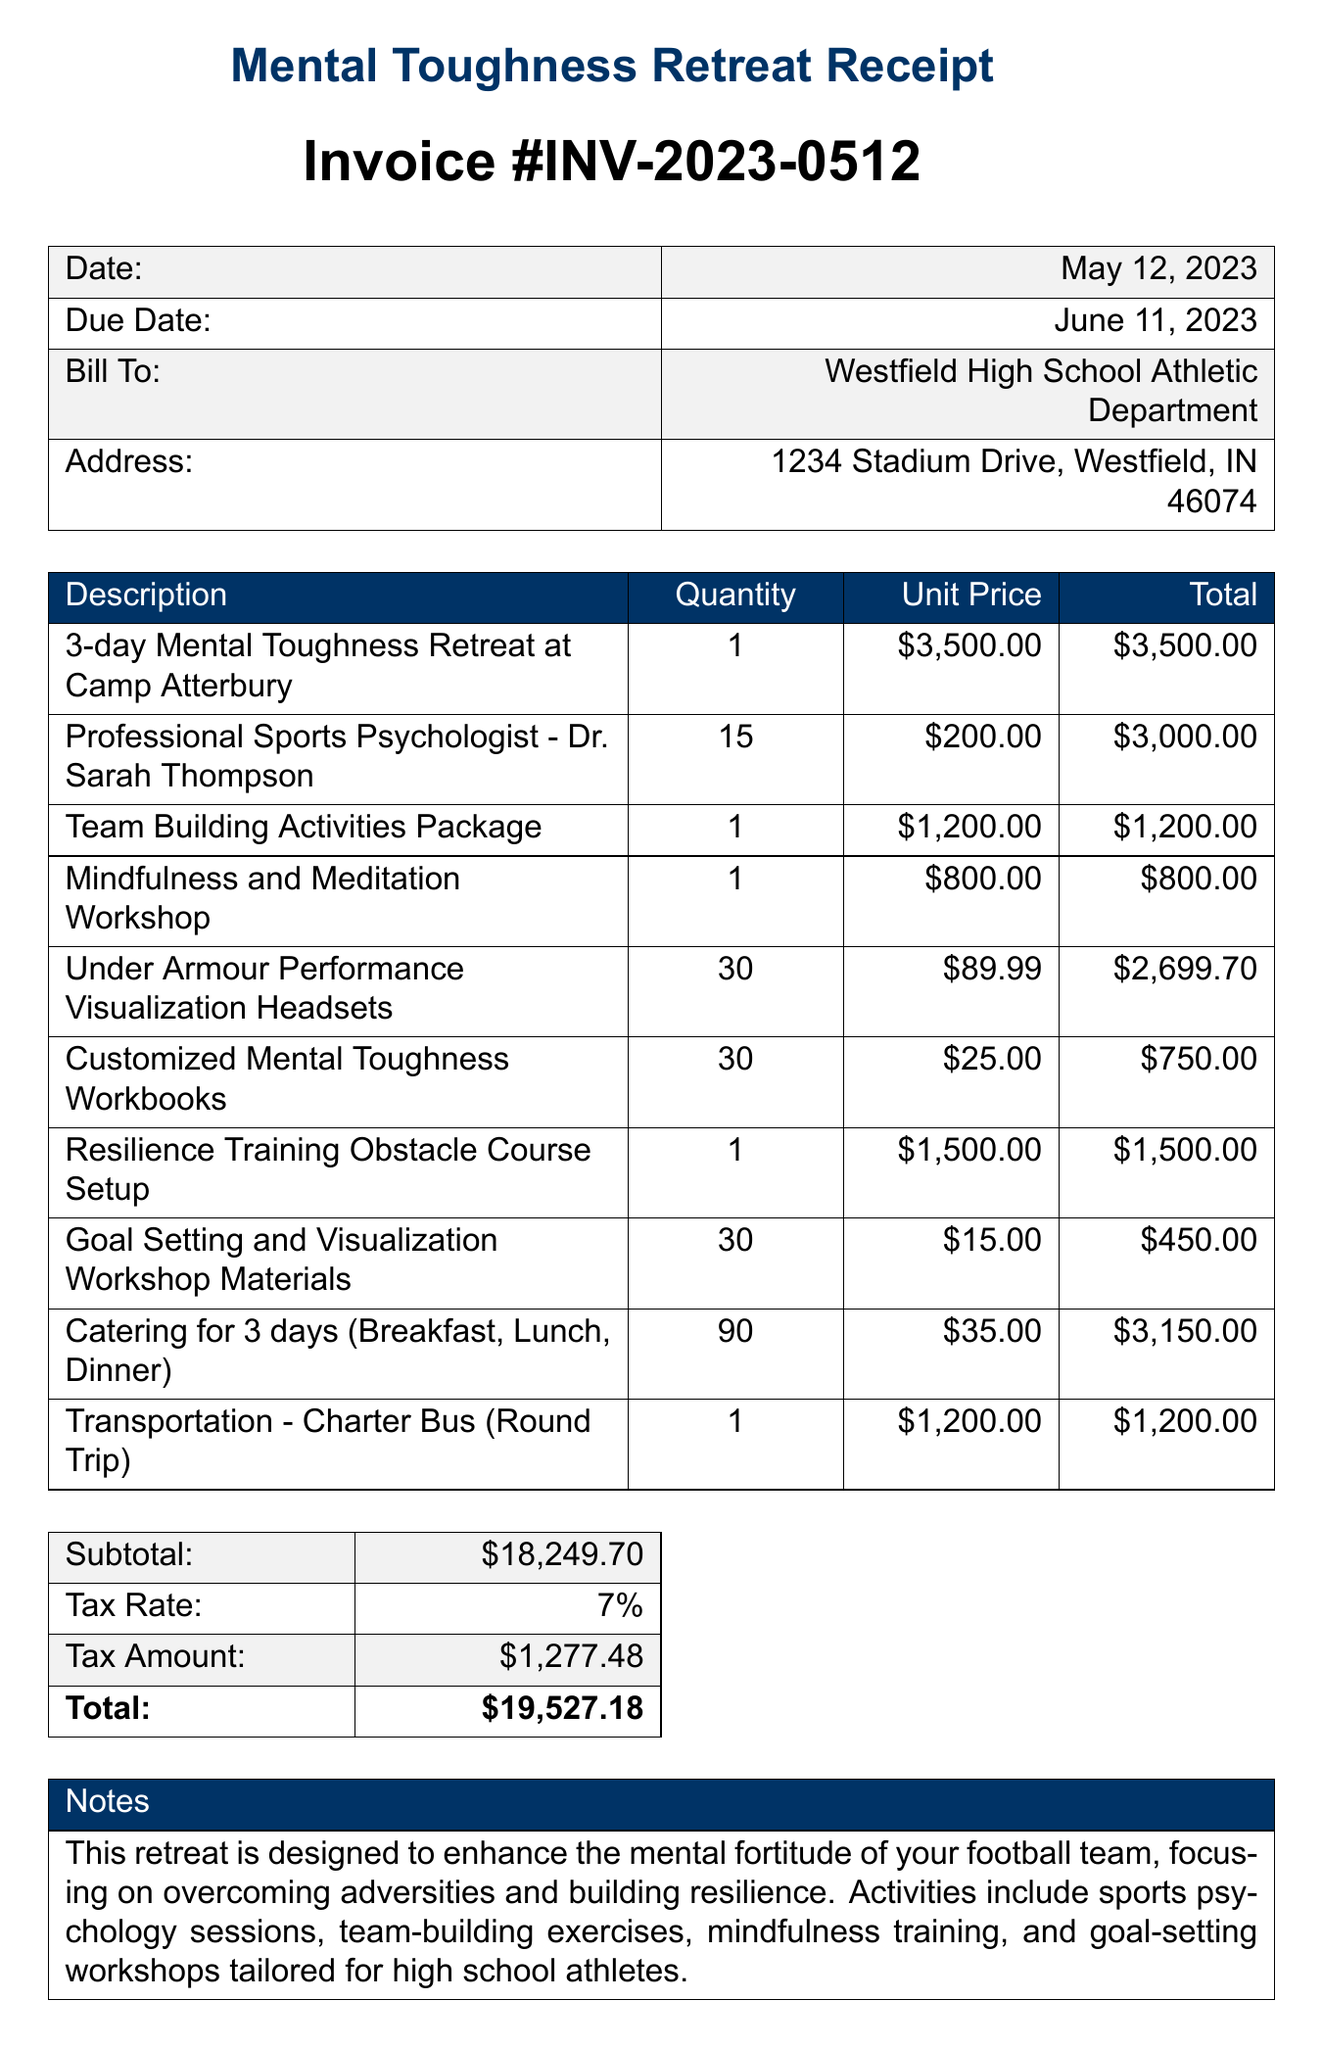What is the invoice number? The invoice number is prominently displayed at the top of the document as INV-2023-0512.
Answer: INV-2023-0512 What is the total amount due? The total amount due is indicated at the bottom of the invoice, which includes the subtotal and tax.
Answer: $19,527.18 Who is the professional sports psychologist mentioned? The document lists Dr. Sarah Thompson as the professional sports psychologist engaged for the retreat.
Answer: Dr. Sarah Thompson How many headsets were ordered? The invoice specifies the quantity of Under Armour Performance Visualization Headsets ordered, which is stated in the item description.
Answer: 30 What is the date of the invoice? The date of the invoice is clearly mentioned at the top of the document.
Answer: May 12, 2023 What type of venue is the retreat held at? The document specifies that the retreat is organized at Camp Atterbury.
Answer: Camp Atterbury How many days does the retreat last? The invoice describes a 3-day Mental Toughness Retreat, indicating the duration of the event.
Answer: 3-day What did the invoice notes highlight about the retreat? The notes section elaborates on the purpose and activities of the retreat, focusing on mental toughness and resilience.
Answer: Enhance mental fortitude What percentage is the tax rate? The tax rate is listed in the subtotal section of the document.
Answer: 7% What kind of workshops are included in the package? The invoice mentions Mindfulness and Meditation Workshop as one of the items included in the services offered at the retreat.
Answer: Mindfulness and Meditation Workshop 